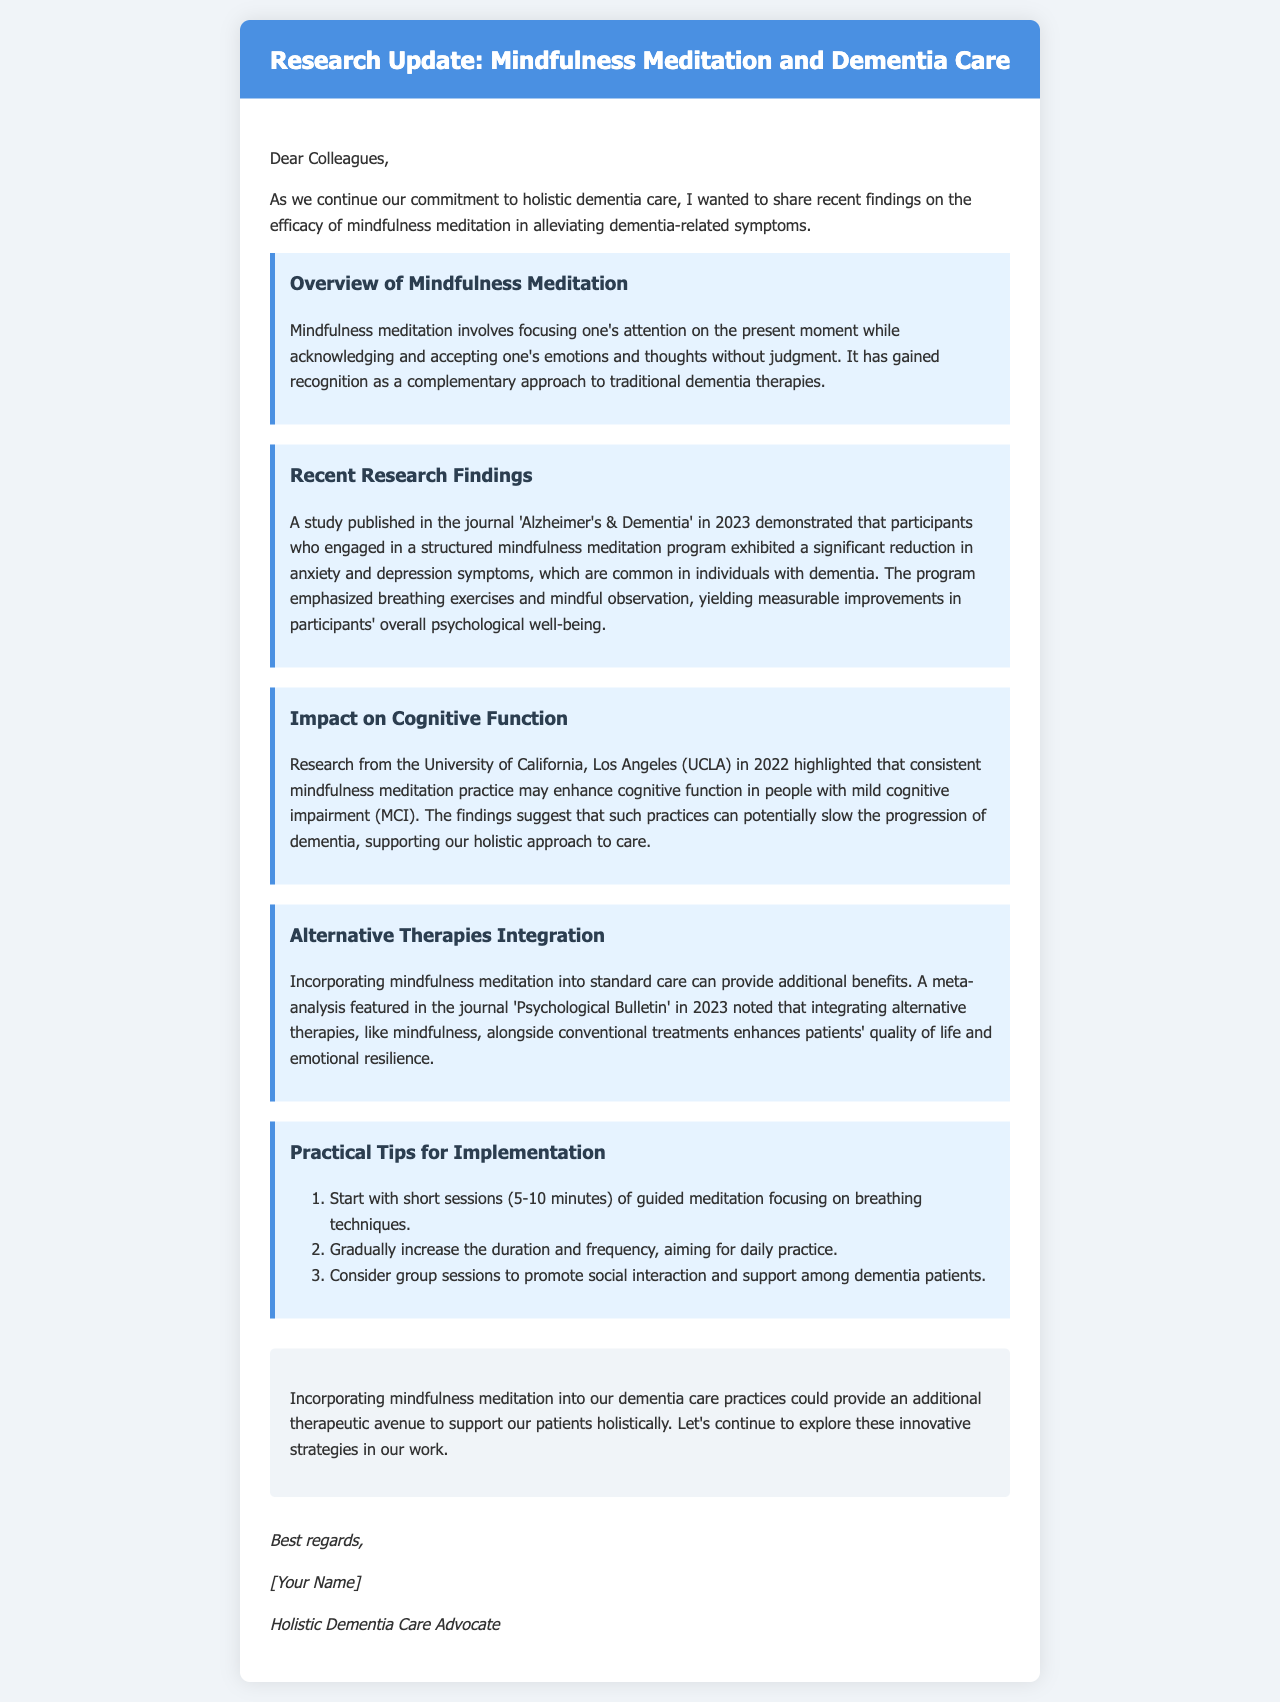What is the title of the research update? The title is the main heading of the document, which provides the central topic being addressed.
Answer: Research Update: Mindfulness Meditation and Dementia Care What year was the study published in 'Alzheimer's & Dementia'? The document mentions a specific year of publication for the research findings related to mindfulness meditation and dementia symptoms.
Answer: 2023 Which university conducted research that highlighted cognitive function enhancement? The document cites a specific university associated with findings on the effects of mindfulness on cognitive abilities.
Answer: University of California, Los Angeles (UCLA) What are the first two tips for practical implementation of mindfulness meditation? The tips are listed in a numbered format, providing specific guidance for integrating mindfulness into care practices.
Answer: Start with short sessions and gradually increase the duration How does mindfulness meditation affect anxiety and depression in dementia patients? The document summarizes the outcomes of a recent study regarding psychological symptoms and their reduction through meditation practices.
Answer: Significant reduction What does the meta-analysis reveal about integrating alternative therapies? The document contains a summary of findings from research on the benefits of combining mindfulness with standard treatments.
Answer: Enhances patients' quality of life Who is the author of the email? The bottom of the document provides the signature section, indicating the author of the email.
Answer: [Your Name] What is the main commitment expressed in the email? The introduction discusses the focus and dedication towards a certain aspect of dementia care that the email addresses.
Answer: Holistic dementia care 